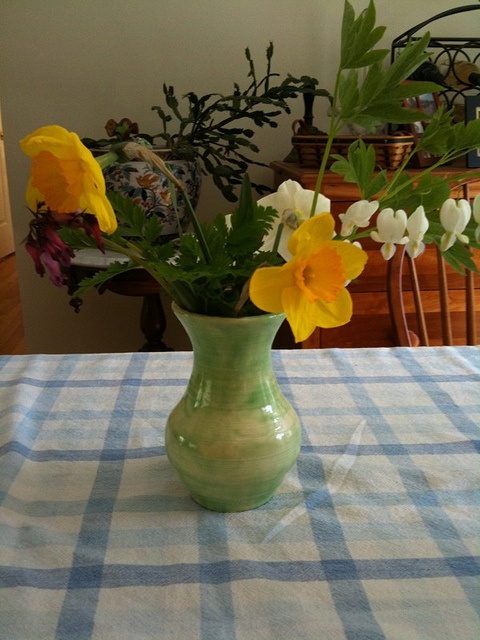Describe the objects in this image and their specific colors. I can see dining table in olive, darkgray, and gray tones, vase in olive, darkgreen, and darkgray tones, and chair in olive, maroon, and brown tones in this image. 